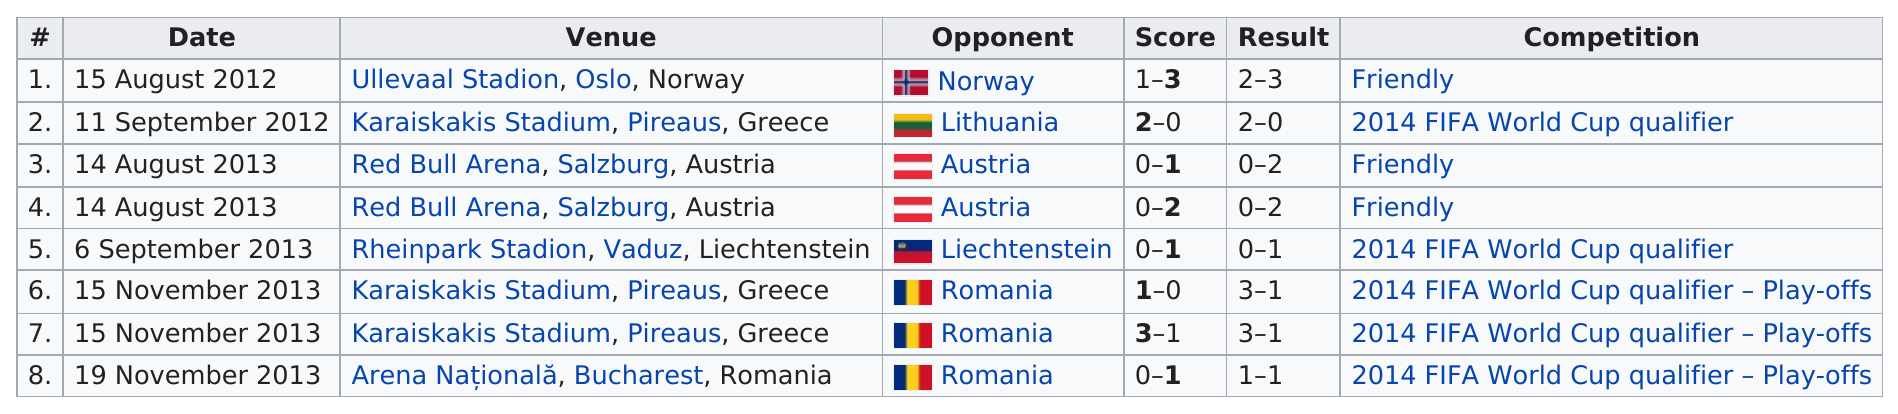Draw attention to some important aspects in this diagram. The highest scores were recorded on August 15th, 2012 and November 15th, 2013. On August 15, 2012, the same score was achieved as on November 15, 2013. Out of the total number of games played, how many had a score of at least two or more points? Liechtenstein's national soccer team played the fewest number of games compared to other teams. Romania was the opponent team that had the most wins. 